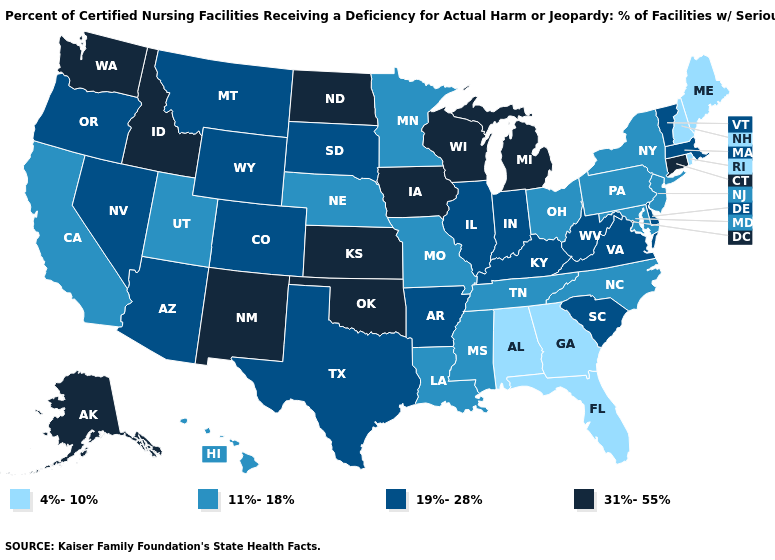Among the states that border Colorado , which have the lowest value?
Short answer required. Nebraska, Utah. Name the states that have a value in the range 4%-10%?
Be succinct. Alabama, Florida, Georgia, Maine, New Hampshire, Rhode Island. Which states have the lowest value in the Northeast?
Answer briefly. Maine, New Hampshire, Rhode Island. Does Georgia have a lower value than New Hampshire?
Write a very short answer. No. Name the states that have a value in the range 4%-10%?
Give a very brief answer. Alabama, Florida, Georgia, Maine, New Hampshire, Rhode Island. What is the value of Maine?
Short answer required. 4%-10%. Name the states that have a value in the range 31%-55%?
Short answer required. Alaska, Connecticut, Idaho, Iowa, Kansas, Michigan, New Mexico, North Dakota, Oklahoma, Washington, Wisconsin. What is the highest value in the South ?
Short answer required. 31%-55%. Does North Dakota have the highest value in the USA?
Answer briefly. Yes. Does Utah have the highest value in the USA?
Concise answer only. No. Name the states that have a value in the range 11%-18%?
Keep it brief. California, Hawaii, Louisiana, Maryland, Minnesota, Mississippi, Missouri, Nebraska, New Jersey, New York, North Carolina, Ohio, Pennsylvania, Tennessee, Utah. Name the states that have a value in the range 19%-28%?
Be succinct. Arizona, Arkansas, Colorado, Delaware, Illinois, Indiana, Kentucky, Massachusetts, Montana, Nevada, Oregon, South Carolina, South Dakota, Texas, Vermont, Virginia, West Virginia, Wyoming. What is the lowest value in states that border Kansas?
Be succinct. 11%-18%. Name the states that have a value in the range 19%-28%?
Keep it brief. Arizona, Arkansas, Colorado, Delaware, Illinois, Indiana, Kentucky, Massachusetts, Montana, Nevada, Oregon, South Carolina, South Dakota, Texas, Vermont, Virginia, West Virginia, Wyoming. What is the value of Oklahoma?
Quick response, please. 31%-55%. 